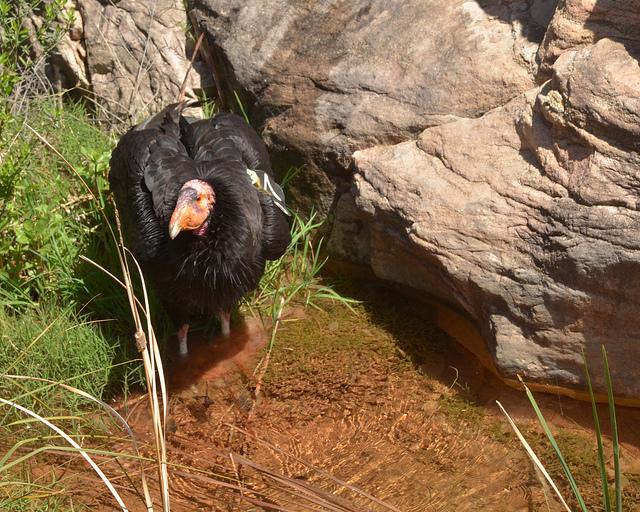Is this a  common city bird?
Keep it brief. No. What color is the bird's head?
Concise answer only. Orange. What kind of animal is this?
Concise answer only. Vulture. Is this bird in water?
Short answer required. No. 